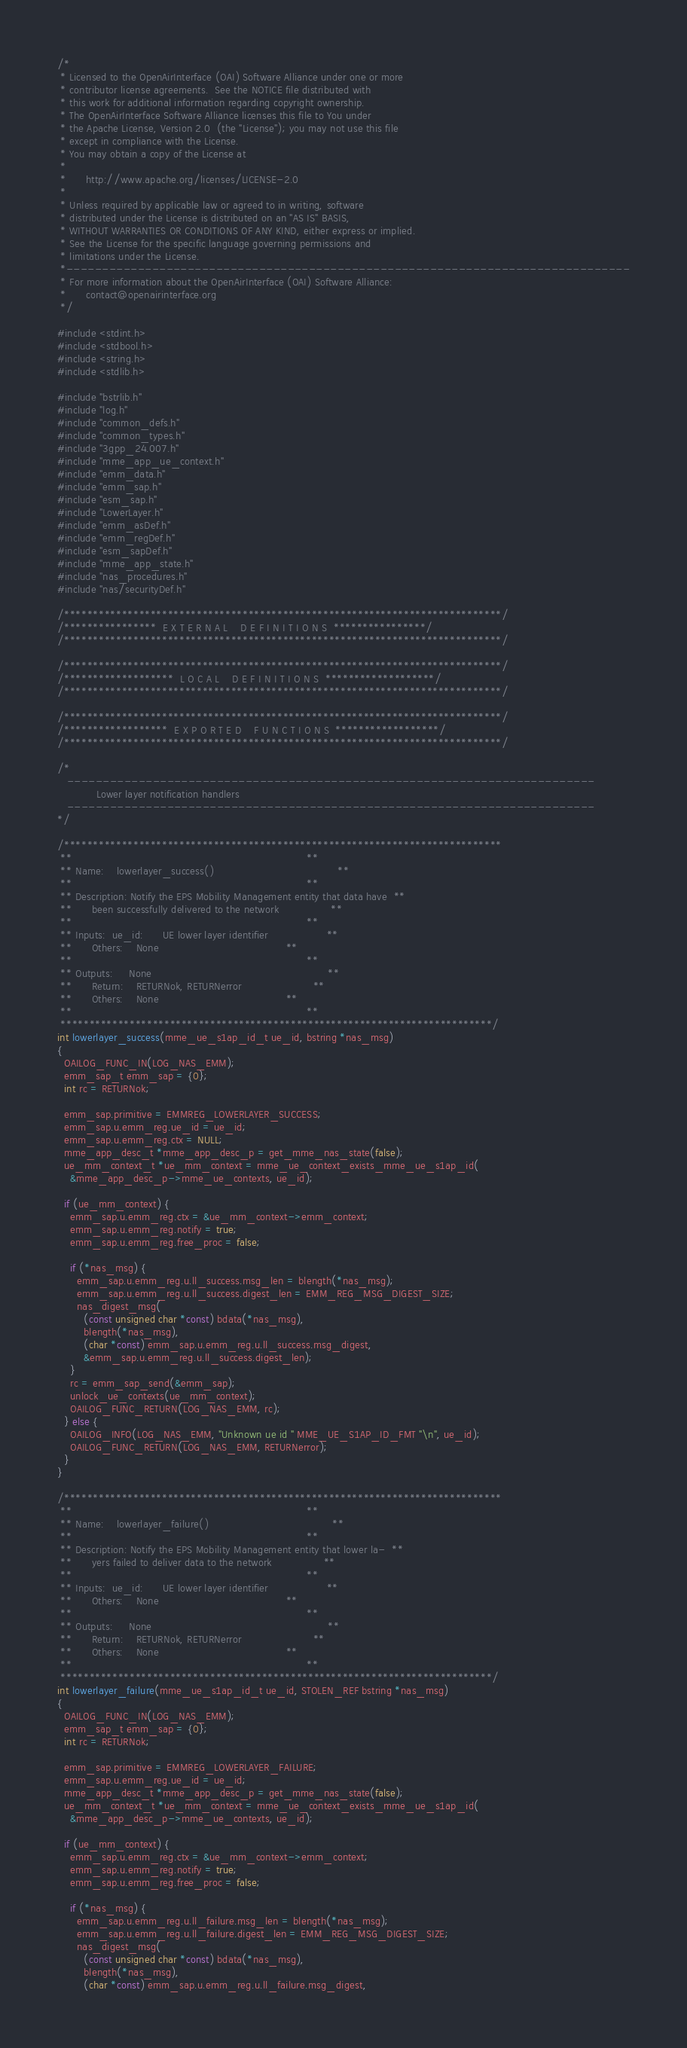Convert code to text. <code><loc_0><loc_0><loc_500><loc_500><_C_>/*
 * Licensed to the OpenAirInterface (OAI) Software Alliance under one or more
 * contributor license agreements.  See the NOTICE file distributed with
 * this work for additional information regarding copyright ownership.
 * The OpenAirInterface Software Alliance licenses this file to You under
 * the Apache License, Version 2.0  (the "License"); you may not use this file
 * except in compliance with the License.
 * You may obtain a copy of the License at
 *
 *      http://www.apache.org/licenses/LICENSE-2.0
 *
 * Unless required by applicable law or agreed to in writing, software
 * distributed under the License is distributed on an "AS IS" BASIS,
 * WITHOUT WARRANTIES OR CONDITIONS OF ANY KIND, either express or implied.
 * See the License for the specific language governing permissions and
 * limitations under the License.
 *-------------------------------------------------------------------------------
 * For more information about the OpenAirInterface (OAI) Software Alliance:
 *      contact@openairinterface.org
 */

#include <stdint.h>
#include <stdbool.h>
#include <string.h>
#include <stdlib.h>

#include "bstrlib.h"
#include "log.h"
#include "common_defs.h"
#include "common_types.h"
#include "3gpp_24.007.h"
#include "mme_app_ue_context.h"
#include "emm_data.h"
#include "emm_sap.h"
#include "esm_sap.h"
#include "LowerLayer.h"
#include "emm_asDef.h"
#include "emm_regDef.h"
#include "esm_sapDef.h"
#include "mme_app_state.h"
#include "nas_procedures.h"
#include "nas/securityDef.h"

/****************************************************************************/
/****************  E X T E R N A L    D E F I N I T I O N S  ****************/
/****************************************************************************/

/****************************************************************************/
/*******************  L O C A L    D E F I N I T I O N S  *******************/
/****************************************************************************/

/****************************************************************************/
/******************  E X P O R T E D    F U N C T I O N S  ******************/
/****************************************************************************/

/*
   --------------------------------------------------------------------------
            Lower layer notification handlers
   --------------------------------------------------------------------------
*/

/****************************************************************************
 **                                                                        **
 ** Name:    lowerlayer_success()                                      **
 **                                                                        **
 ** Description: Notify the EPS Mobility Management entity that data have  **
 **      been successfully delivered to the network                **
 **                                                                        **
 ** Inputs:  ue_id:      UE lower layer identifier                  **
 **      Others:    None                                       **
 **                                                                        **
 ** Outputs:     None                                                      **
 **      Return:    RETURNok, RETURNerror                      **
 **      Others:    None                                       **
 **                                                                        **
 ***************************************************************************/
int lowerlayer_success(mme_ue_s1ap_id_t ue_id, bstring *nas_msg)
{
  OAILOG_FUNC_IN(LOG_NAS_EMM);
  emm_sap_t emm_sap = {0};
  int rc = RETURNok;

  emm_sap.primitive = EMMREG_LOWERLAYER_SUCCESS;
  emm_sap.u.emm_reg.ue_id = ue_id;
  emm_sap.u.emm_reg.ctx = NULL;
  mme_app_desc_t *mme_app_desc_p = get_mme_nas_state(false);
  ue_mm_context_t *ue_mm_context = mme_ue_context_exists_mme_ue_s1ap_id(
    &mme_app_desc_p->mme_ue_contexts, ue_id);

  if (ue_mm_context) {
    emm_sap.u.emm_reg.ctx = &ue_mm_context->emm_context;
    emm_sap.u.emm_reg.notify = true;
    emm_sap.u.emm_reg.free_proc = false;

    if (*nas_msg) {
      emm_sap.u.emm_reg.u.ll_success.msg_len = blength(*nas_msg);
      emm_sap.u.emm_reg.u.ll_success.digest_len = EMM_REG_MSG_DIGEST_SIZE;
      nas_digest_msg(
        (const unsigned char *const) bdata(*nas_msg),
        blength(*nas_msg),
        (char *const) emm_sap.u.emm_reg.u.ll_success.msg_digest,
        &emm_sap.u.emm_reg.u.ll_success.digest_len);
    }
    rc = emm_sap_send(&emm_sap);
    unlock_ue_contexts(ue_mm_context);
    OAILOG_FUNC_RETURN(LOG_NAS_EMM, rc);
  } else {
    OAILOG_INFO(LOG_NAS_EMM, "Unknown ue id " MME_UE_S1AP_ID_FMT "\n", ue_id);
    OAILOG_FUNC_RETURN(LOG_NAS_EMM, RETURNerror);
  }
}

/****************************************************************************
 **                                                                        **
 ** Name:    lowerlayer_failure()                                      **
 **                                                                        **
 ** Description: Notify the EPS Mobility Management entity that lower la-  **
 **      yers failed to deliver data to the network                **
 **                                                                        **
 ** Inputs:  ue_id:      UE lower layer identifier                  **
 **      Others:    None                                       **
 **                                                                        **
 ** Outputs:     None                                                      **
 **      Return:    RETURNok, RETURNerror                      **
 **      Others:    None                                       **
 **                                                                        **
 ***************************************************************************/
int lowerlayer_failure(mme_ue_s1ap_id_t ue_id, STOLEN_REF bstring *nas_msg)
{
  OAILOG_FUNC_IN(LOG_NAS_EMM);
  emm_sap_t emm_sap = {0};
  int rc = RETURNok;

  emm_sap.primitive = EMMREG_LOWERLAYER_FAILURE;
  emm_sap.u.emm_reg.ue_id = ue_id;
  mme_app_desc_t *mme_app_desc_p = get_mme_nas_state(false);
  ue_mm_context_t *ue_mm_context = mme_ue_context_exists_mme_ue_s1ap_id(
    &mme_app_desc_p->mme_ue_contexts, ue_id);

  if (ue_mm_context) {
    emm_sap.u.emm_reg.ctx = &ue_mm_context->emm_context;
    emm_sap.u.emm_reg.notify = true;
    emm_sap.u.emm_reg.free_proc = false;

    if (*nas_msg) {
      emm_sap.u.emm_reg.u.ll_failure.msg_len = blength(*nas_msg);
      emm_sap.u.emm_reg.u.ll_failure.digest_len = EMM_REG_MSG_DIGEST_SIZE;
      nas_digest_msg(
        (const unsigned char *const) bdata(*nas_msg),
        blength(*nas_msg),
        (char *const) emm_sap.u.emm_reg.u.ll_failure.msg_digest,</code> 